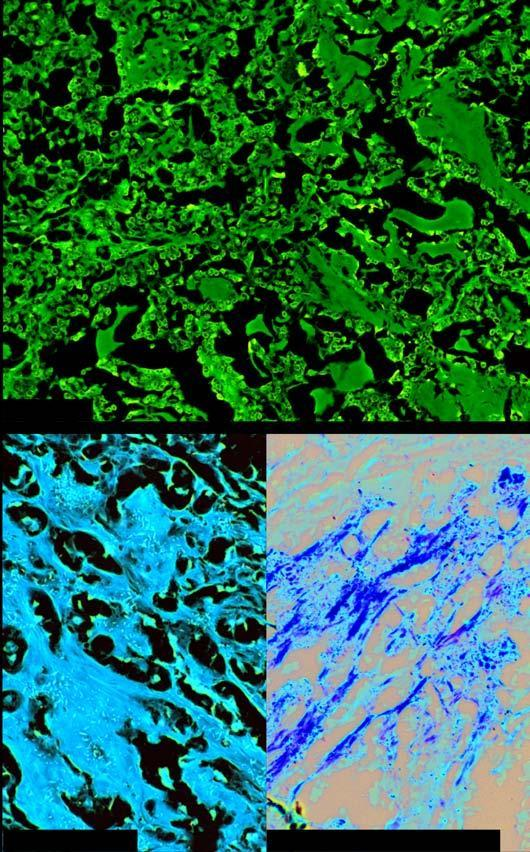does the nucleus show congophilia which depicts apple-green birefringence under polarising microscopy?
Answer the question using a single word or phrase. No 